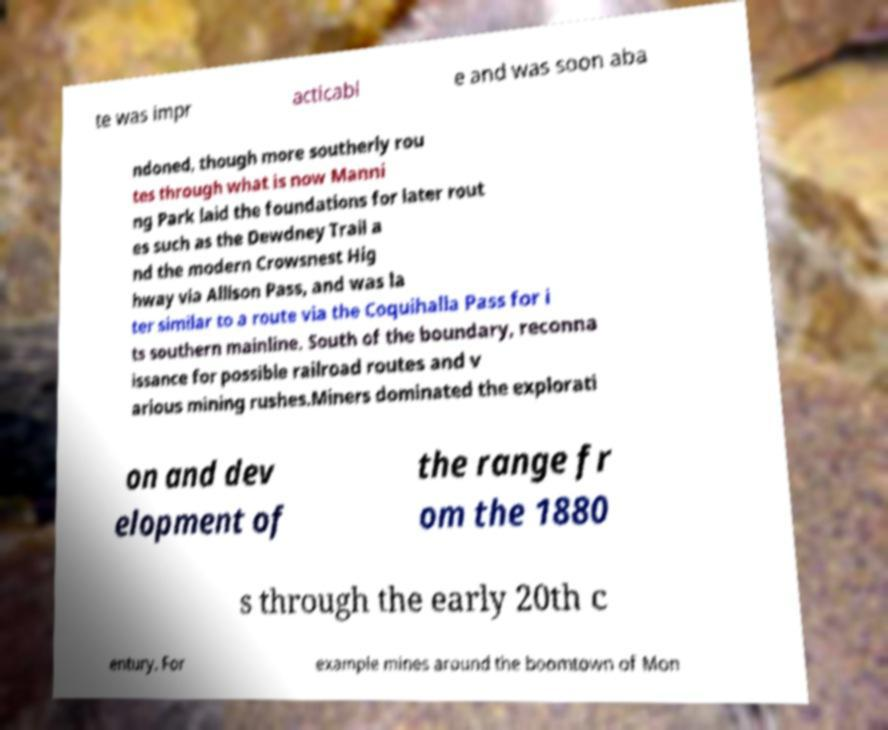What messages or text are displayed in this image? I need them in a readable, typed format. te was impr acticabl e and was soon aba ndoned, though more southerly rou tes through what is now Manni ng Park laid the foundations for later rout es such as the Dewdney Trail a nd the modern Crowsnest Hig hway via Allison Pass, and was la ter similar to a route via the Coquihalla Pass for i ts southern mainline. South of the boundary, reconna issance for possible railroad routes and v arious mining rushes.Miners dominated the explorati on and dev elopment of the range fr om the 1880 s through the early 20th c entury. For example mines around the boomtown of Mon 